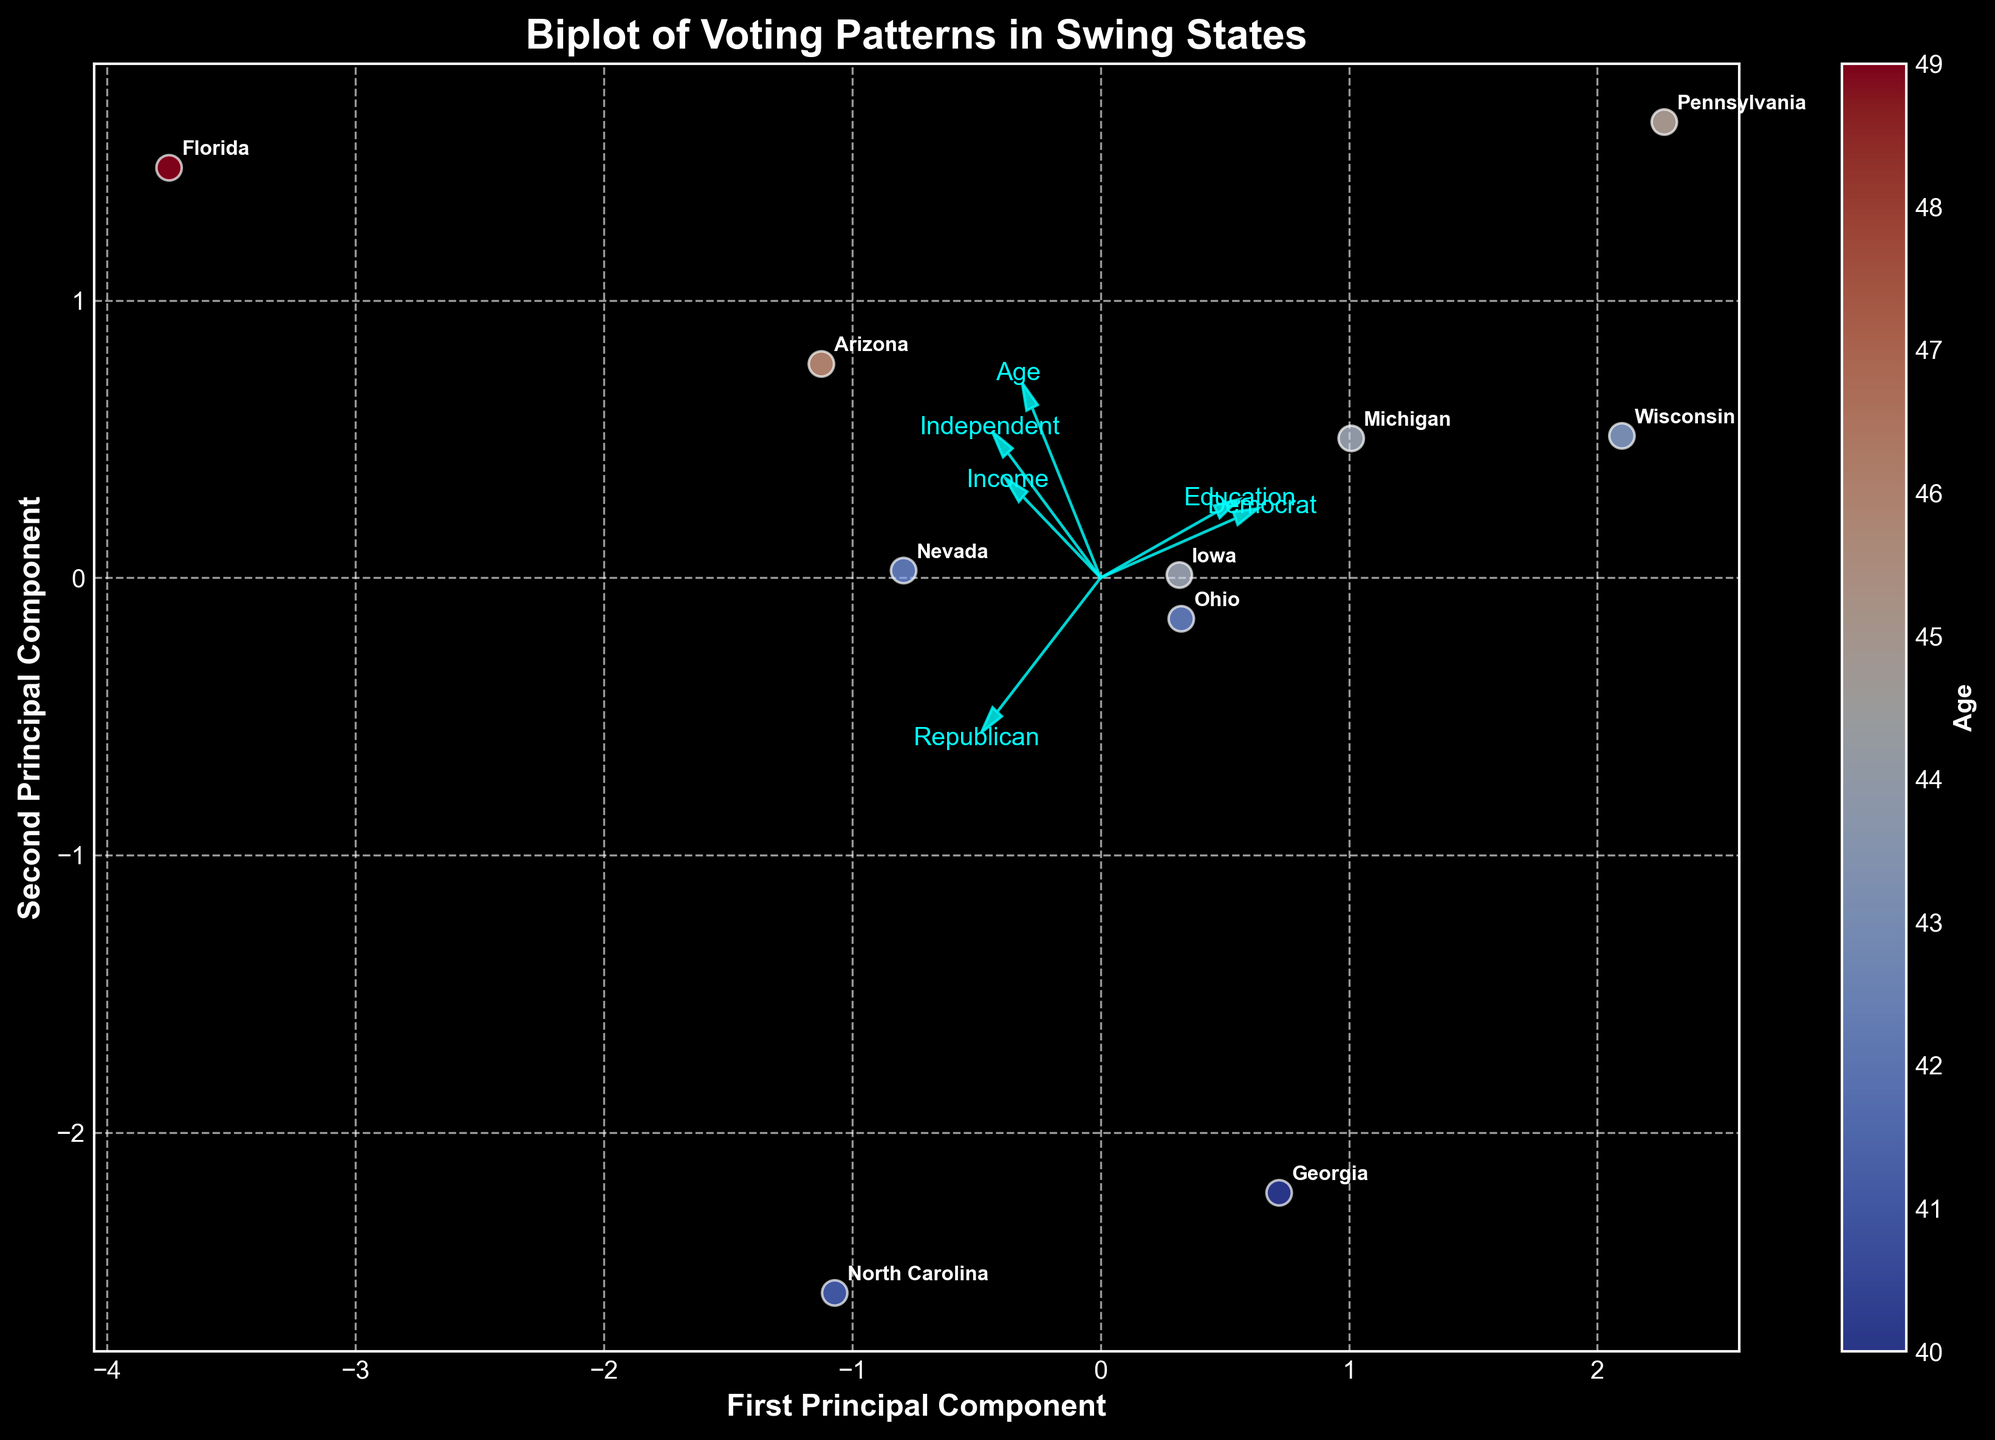How many swing states are represented in the plot? The plot contains one data point for each swing state. By counting the number of data points or the state labels, we can determine the number of swing states represented.
Answer: 10 What is plotted as the color gradient in the scatter points? Each scatter point represents a state and the color gradient represents the age variable. A color bar labeled 'Age' confirms this.
Answer: Age Which state has the highest first principal component value? By locating the state label furthest to the right on the x-axis (First Principal Component), we can identify the state with the highest value.
Answer: Pennsylvania Which two features have arrows pointing most similarly in direction? By observing the directions of the feature arrows, we can identify which two are most parallel or closely aligned.
Answer: Democrat and Independent What is the title of the biplot? The plot title is typically found at the top of the figure.
Answer: Biplot of Voting Patterns in Swing States How does education level appear to influence party affiliation? The direction and relative position of the Education arrow compared to the Democrat, Republican, and Independent arrows can provide insights into this relationship.
Answer: Higher education correlates more with Democrat affiliation Which feature has the smallest arrow? The smallest arrow can be identified by comparing the lengths of all the feature arrows from the origin point.
Answer: Independent Which state is closest to the origin in the biplot? By identifying the state label nearest to the (0,0) coordinate, we can determine the closest state.
Answer: North Carolina If a state has high income, which direction would it lie in the biplot? Analyzing the direction of the 'Income' arrow, we can infer that states with high income values will be positioned in that direction relative to the origin.
Answer: Toward the right and upward Which component explains more variance in the data? By examining the axis labels or the PCA results explanation, we can determine which component, typically specified in the plot or legend, explains more variance.
Answer: First Principal Component 